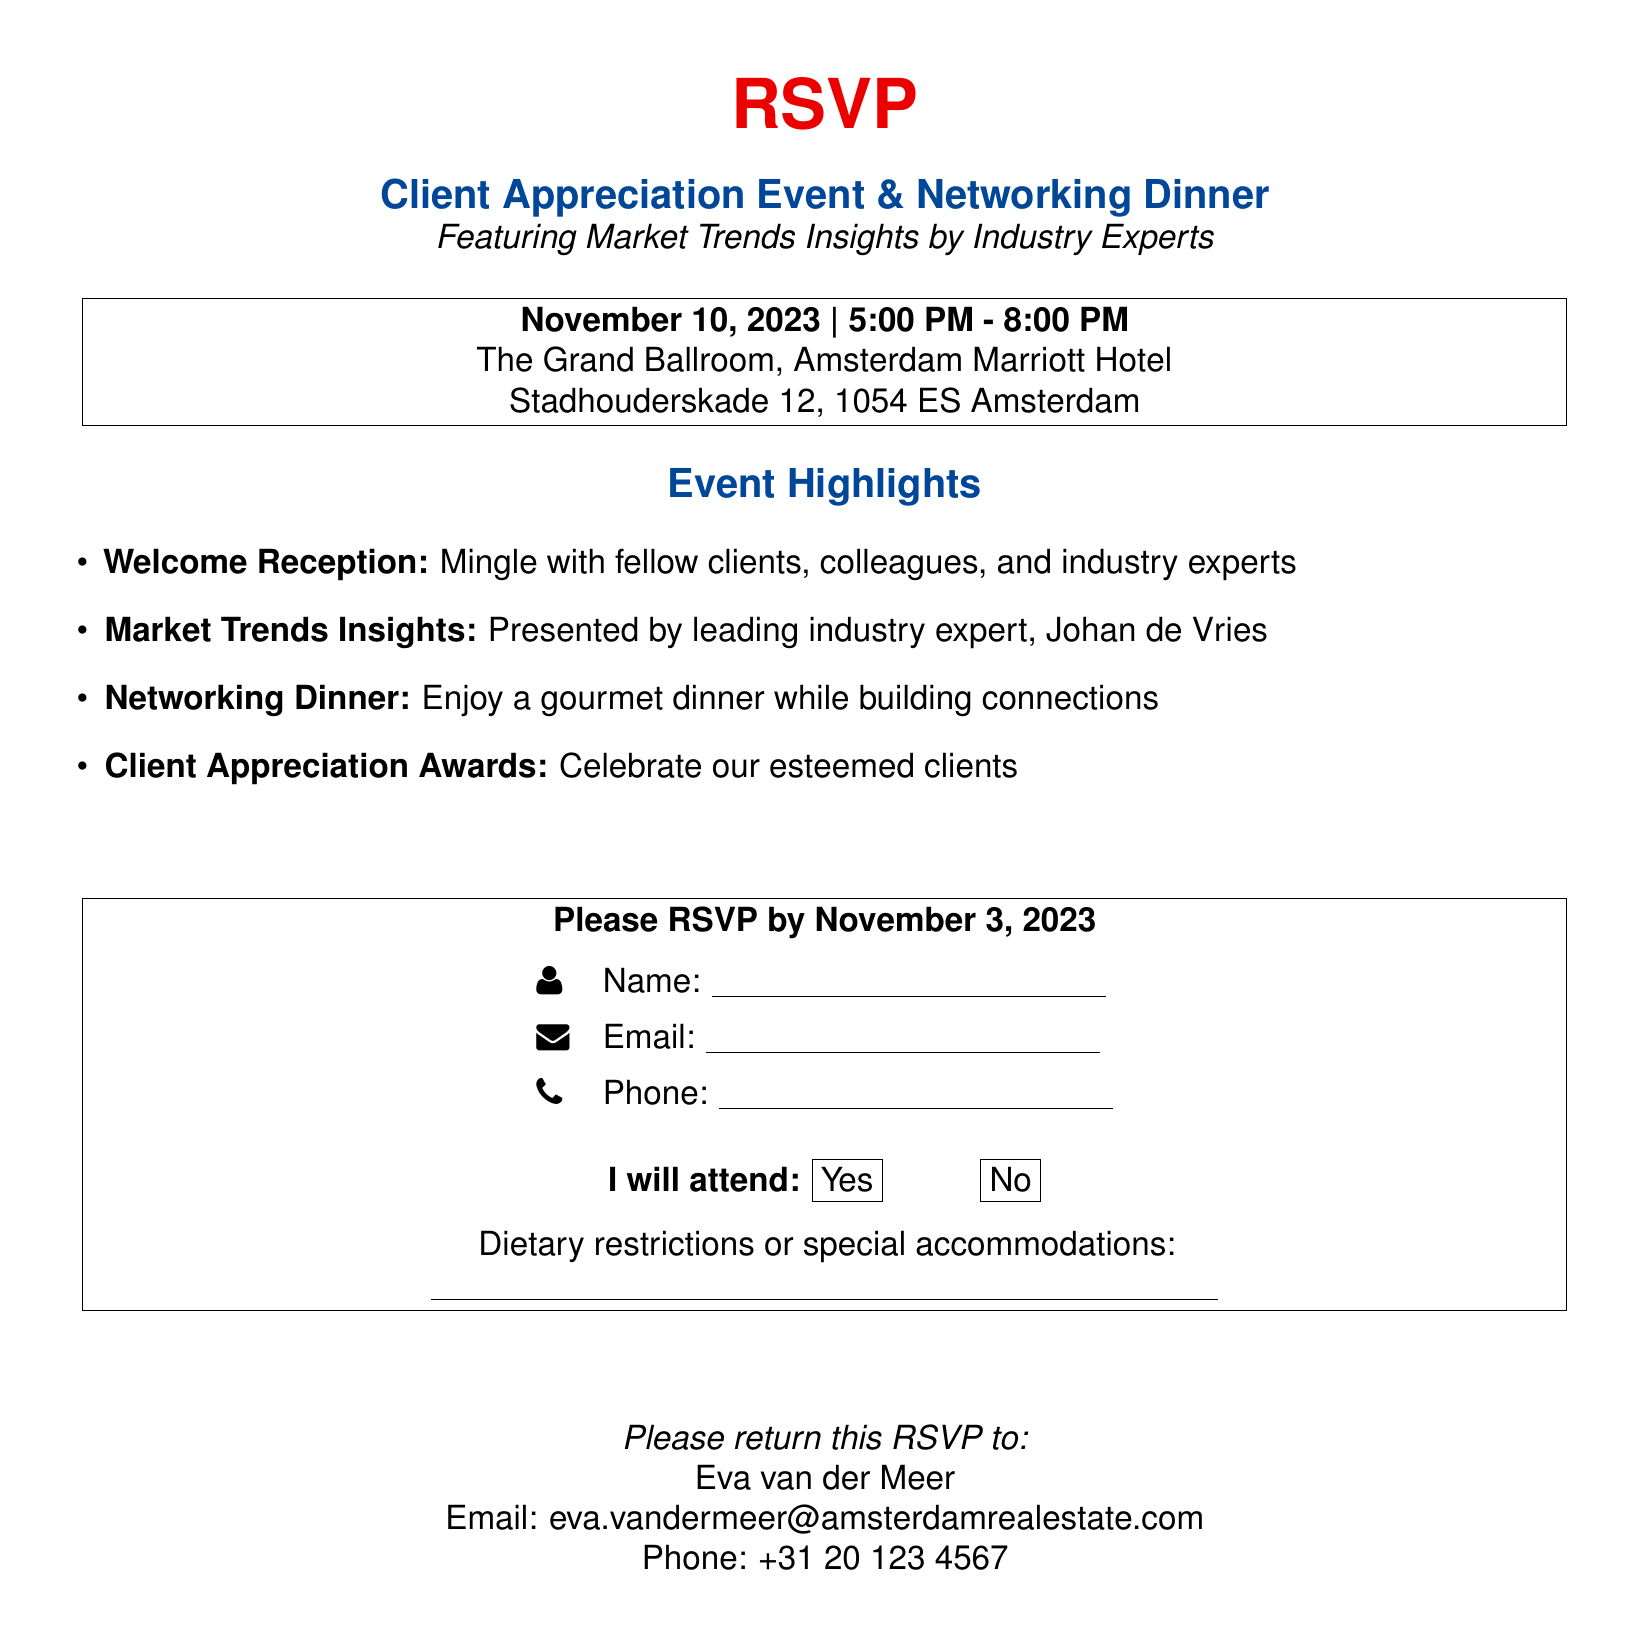What is the date of the event? The date of the event is specified prominently in the document as November 10, 2023.
Answer: November 10, 2023 Where is the event held? The location of the event is mentioned in the document as The Grand Ballroom, Amsterdam Marriott Hotel.
Answer: The Grand Ballroom, Amsterdam Marriott Hotel Who is presenting the Market Trends Insights? The document indicates that the presentation on Market Trends Insights will be given by Johan de Vries.
Answer: Johan de Vries What time does the event start? The start time of the event is clearly stated in the document as 5:00 PM.
Answer: 5:00 PM What must attendees do by November 3, 2023? The document instructs attendees to RSVP by that date.
Answer: RSVP What type of reception is included in the event? The document mentions a Welcome Reception as part of the event highlights.
Answer: Welcome Reception Is there a contact person listed for returning the RSVP? The document provides the name of Eva van der Meer as the contact person for RSVP returns.
Answer: Eva van der Meer What is the email address for the contact person? The email address for returning the RSVP is specified in the document as eva.vandermeer@amsterdamrealestate.com.
Answer: eva.vandermeer@amsterdamrealestate.com 